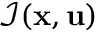Convert formula to latex. <formula><loc_0><loc_0><loc_500><loc_500>\mathcal { I } ( x , u )</formula> 